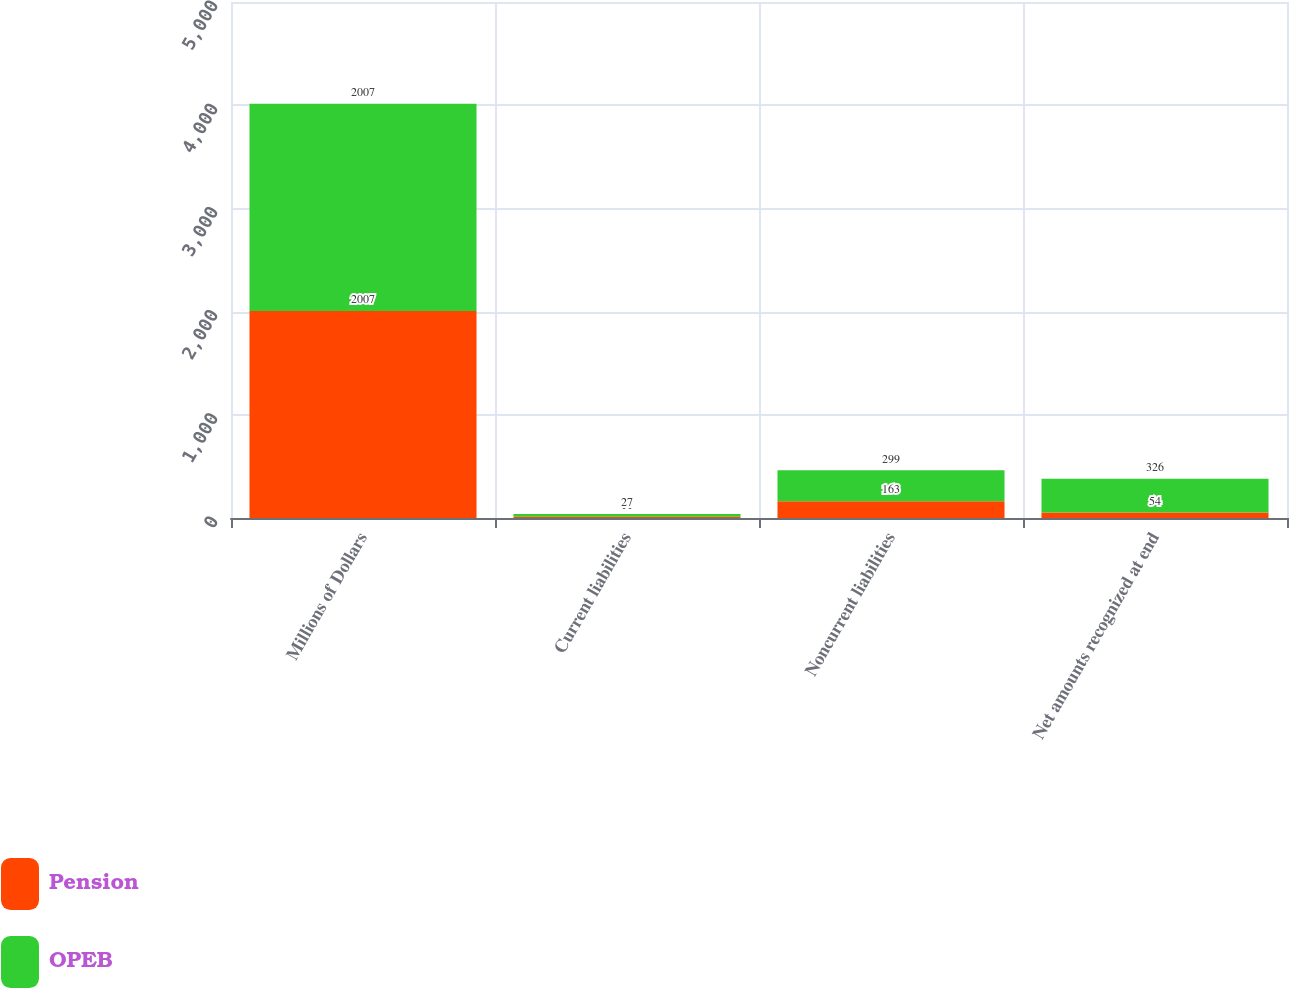<chart> <loc_0><loc_0><loc_500><loc_500><stacked_bar_chart><ecel><fcel>Millions of Dollars<fcel>Current liabilities<fcel>Noncurrent liabilities<fcel>Net amounts recognized at end<nl><fcel>Pension<fcel>2007<fcel>11<fcel>163<fcel>54<nl><fcel>OPEB<fcel>2007<fcel>27<fcel>299<fcel>326<nl></chart> 